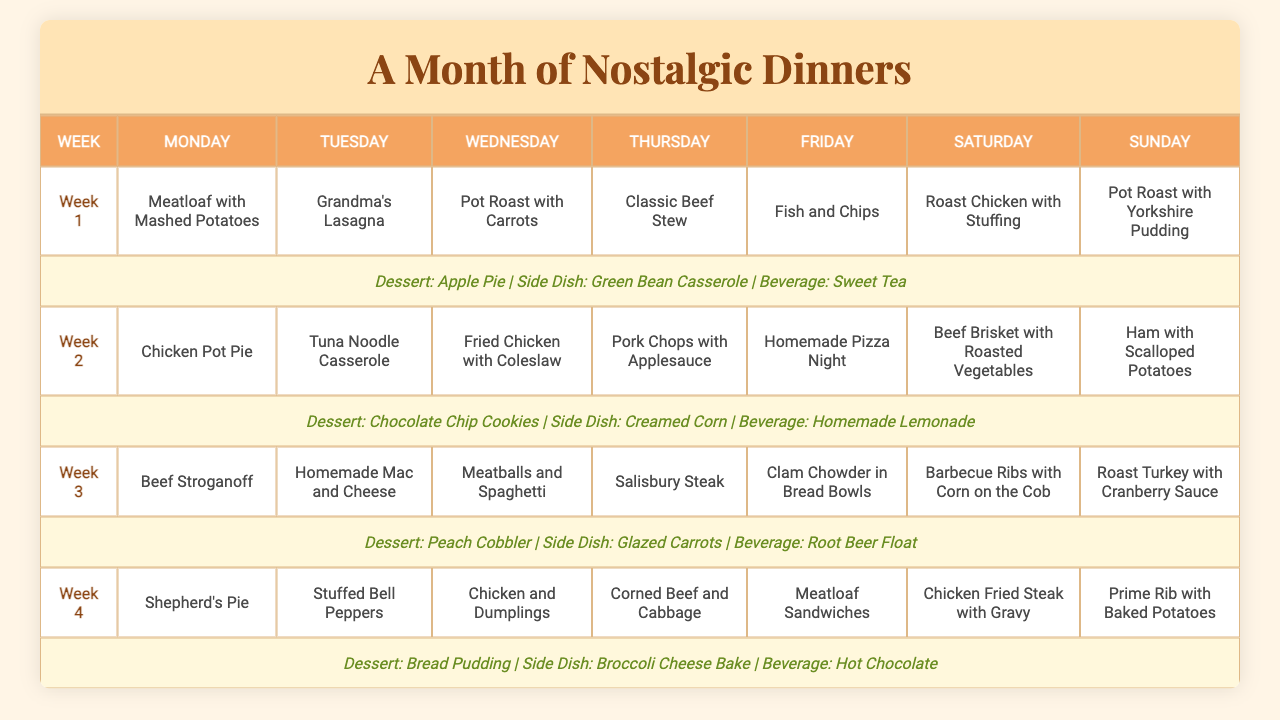What is the meal planned for Tuesday in Week 3? For Week 3, the table indicates that the meal planned for Tuesday is "Homemade Mac and Cheese."
Answer: Homemade Mac and Cheese Which dessert is associated with Week 2? According to the table, the dessert scheduled for Week 2 is "Chocolate Chip Cookies."
Answer: Chocolate Chip Cookies Is "Fish and Chips" served on a Saturday? The table shows that "Fish and Chips" is served on a Friday, so the statement is false.
Answer: No What is the side dish served with "Meatloaf with Mashed Potatoes"? Referring to Week 1, the side dish listed with "Meatloaf with Mashed Potatoes" is "Green Bean Casserole."
Answer: Green Bean Casserole In which week is "Roast Turkey with Cranberry Sauce" served, and what is the dessert for that week? The table indicates that "Roast Turkey with Cranberry Sauce" is served in Week 3, and the associated dessert for that week is "Peach Cobbler."
Answer: Week 3, Peach Cobbler What are the two beverages served on Sunday across the weeks? Checking the table, the two beverages served on Sunday in the schedule are "Sweet Tea" in Week 1 and "Hot Chocolate" in Week 4.
Answer: Sweet Tea and Hot Chocolate Calculate the number of different main dishes served on Saturdays for the month. There are four unique main dishes served on Saturdays (Roast Chicken, Beef Brisket, Barbecue Ribs, Chicken Fried Steak), meaning four different options.
Answer: 4 Is there a week where "Classic Beef Stew" is the main dish on Thursday? Yes, the table confirms that "Classic Beef Stew" is indeed scheduled for Thursday of Week 2.
Answer: Yes Which week features the highest number of meat-based dinners (considering meatloaf, beef, chicken, and turkey)? In Week 4, there are four meat-based dinners (Shepherd's Pie, Stuffed Bell Peppers, Chicken and Dumplings, Corned Beef and Cabbage) compared to other weeks. Therefore, Week 4 has the highest.
Answer: Week 4 What is the average number of desserts served across the four weeks? The table lists one dessert per week over four weeks, so the average is also one dessert per week (4/4).
Answer: 1 